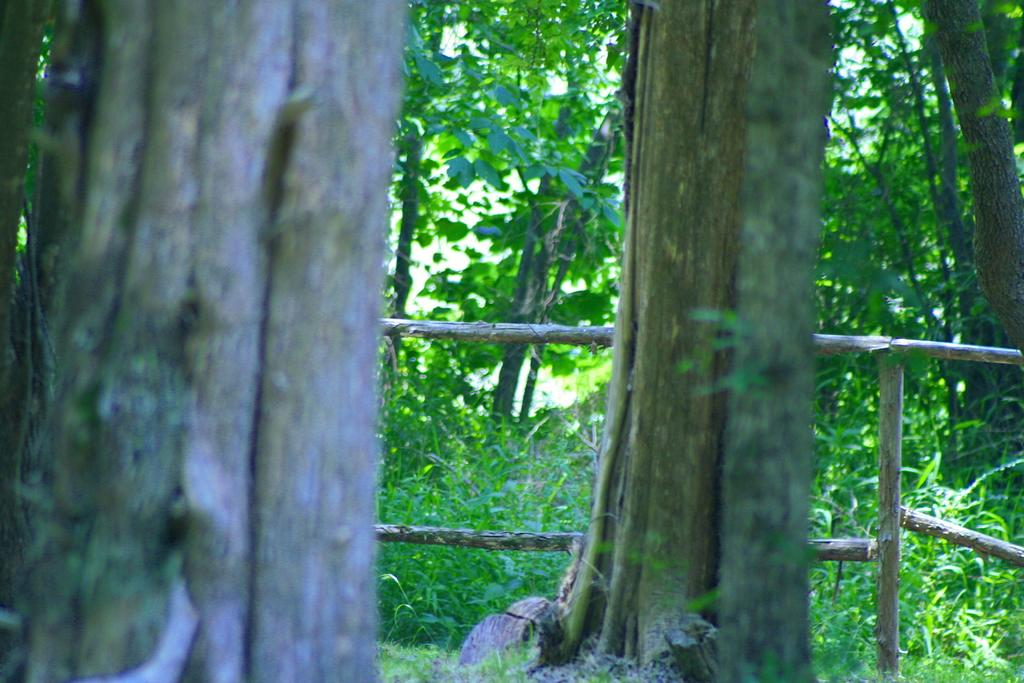What type of vegetation can be seen in the image? There are trees and grass in the image. Can you describe the natural environment depicted in the image? The image features trees and grass, which suggests a natural setting. What color of paint is being used by the porter in the image? There is no paint or porter present in the image; it features trees and grass. 